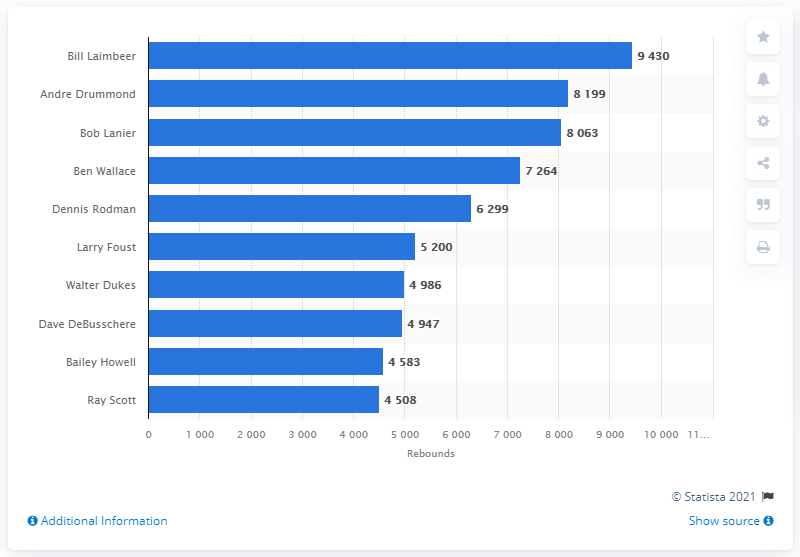Outline some significant characteristics in this image. Bill Laimbeer is the career rebounds leader of the Detroit Pistons. 